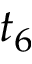Convert formula to latex. <formula><loc_0><loc_0><loc_500><loc_500>t _ { 6 }</formula> 